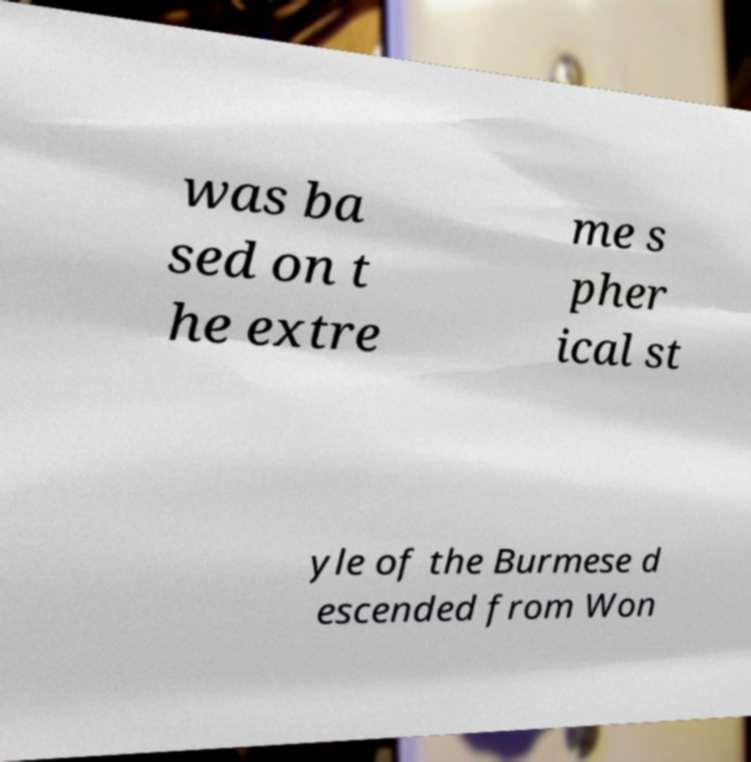Can you read and provide the text displayed in the image?This photo seems to have some interesting text. Can you extract and type it out for me? was ba sed on t he extre me s pher ical st yle of the Burmese d escended from Won 